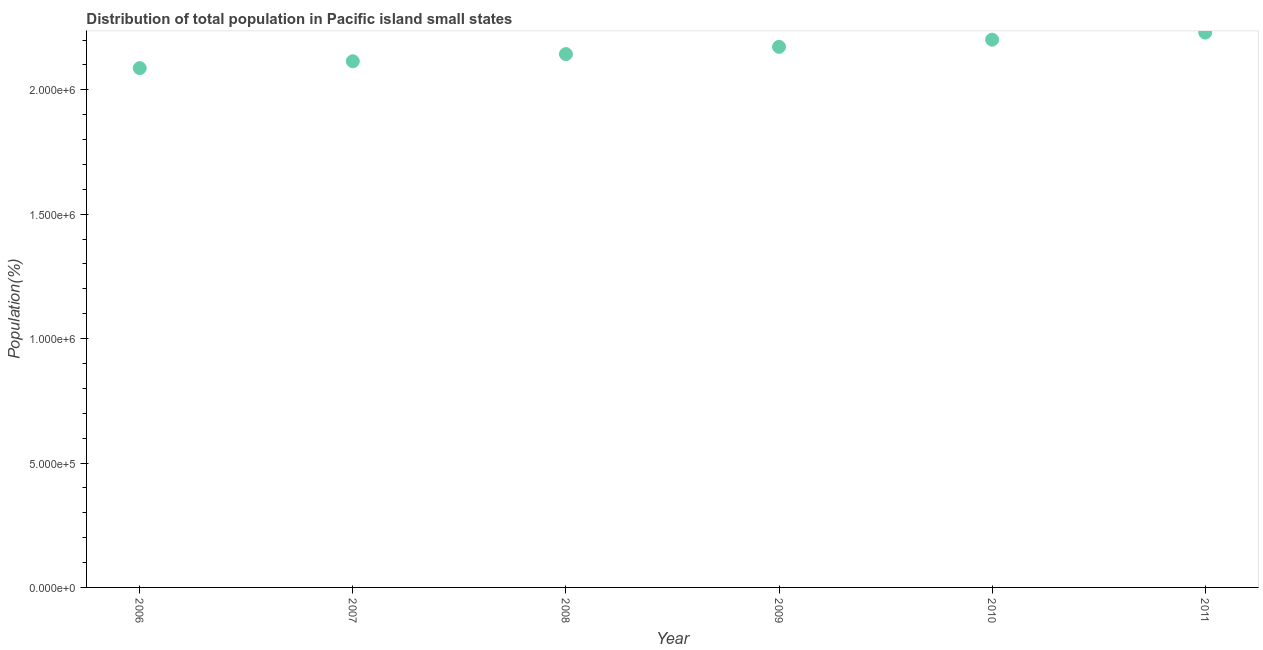What is the population in 2008?
Make the answer very short. 2.14e+06. Across all years, what is the maximum population?
Provide a short and direct response. 2.23e+06. Across all years, what is the minimum population?
Your answer should be compact. 2.09e+06. In which year was the population maximum?
Your answer should be very brief. 2011. What is the sum of the population?
Keep it short and to the point. 1.29e+07. What is the difference between the population in 2007 and 2011?
Offer a very short reply. -1.15e+05. What is the average population per year?
Ensure brevity in your answer.  2.16e+06. What is the median population?
Keep it short and to the point. 2.16e+06. In how many years, is the population greater than 1100000 %?
Ensure brevity in your answer.  6. What is the ratio of the population in 2006 to that in 2009?
Offer a terse response. 0.96. Is the population in 2008 less than that in 2011?
Your answer should be compact. Yes. What is the difference between the highest and the second highest population?
Your answer should be very brief. 2.84e+04. What is the difference between the highest and the lowest population?
Keep it short and to the point. 1.43e+05. In how many years, is the population greater than the average population taken over all years?
Offer a terse response. 3. Does the population monotonically increase over the years?
Offer a very short reply. Yes. How many dotlines are there?
Your answer should be compact. 1. What is the difference between two consecutive major ticks on the Y-axis?
Provide a succinct answer. 5.00e+05. What is the title of the graph?
Make the answer very short. Distribution of total population in Pacific island small states . What is the label or title of the X-axis?
Your response must be concise. Year. What is the label or title of the Y-axis?
Provide a succinct answer. Population(%). What is the Population(%) in 2006?
Provide a short and direct response. 2.09e+06. What is the Population(%) in 2007?
Offer a very short reply. 2.11e+06. What is the Population(%) in 2008?
Make the answer very short. 2.14e+06. What is the Population(%) in 2009?
Ensure brevity in your answer.  2.17e+06. What is the Population(%) in 2010?
Ensure brevity in your answer.  2.20e+06. What is the Population(%) in 2011?
Offer a terse response. 2.23e+06. What is the difference between the Population(%) in 2006 and 2007?
Make the answer very short. -2.75e+04. What is the difference between the Population(%) in 2006 and 2008?
Offer a terse response. -5.63e+04. What is the difference between the Population(%) in 2006 and 2009?
Your response must be concise. -8.54e+04. What is the difference between the Population(%) in 2006 and 2010?
Your answer should be compact. -1.14e+05. What is the difference between the Population(%) in 2006 and 2011?
Make the answer very short. -1.43e+05. What is the difference between the Population(%) in 2007 and 2008?
Offer a very short reply. -2.88e+04. What is the difference between the Population(%) in 2007 and 2009?
Your response must be concise. -5.79e+04. What is the difference between the Population(%) in 2007 and 2010?
Keep it short and to the point. -8.68e+04. What is the difference between the Population(%) in 2007 and 2011?
Keep it short and to the point. -1.15e+05. What is the difference between the Population(%) in 2008 and 2009?
Your response must be concise. -2.92e+04. What is the difference between the Population(%) in 2008 and 2010?
Keep it short and to the point. -5.80e+04. What is the difference between the Population(%) in 2008 and 2011?
Give a very brief answer. -8.65e+04. What is the difference between the Population(%) in 2009 and 2010?
Provide a succinct answer. -2.89e+04. What is the difference between the Population(%) in 2009 and 2011?
Your response must be concise. -5.73e+04. What is the difference between the Population(%) in 2010 and 2011?
Provide a succinct answer. -2.84e+04. What is the ratio of the Population(%) in 2006 to that in 2007?
Your answer should be very brief. 0.99. What is the ratio of the Population(%) in 2006 to that in 2009?
Make the answer very short. 0.96. What is the ratio of the Population(%) in 2006 to that in 2010?
Make the answer very short. 0.95. What is the ratio of the Population(%) in 2006 to that in 2011?
Provide a succinct answer. 0.94. What is the ratio of the Population(%) in 2007 to that in 2009?
Ensure brevity in your answer.  0.97. What is the ratio of the Population(%) in 2007 to that in 2010?
Keep it short and to the point. 0.96. What is the ratio of the Population(%) in 2007 to that in 2011?
Offer a terse response. 0.95. What is the ratio of the Population(%) in 2008 to that in 2009?
Provide a short and direct response. 0.99. What is the ratio of the Population(%) in 2008 to that in 2010?
Provide a succinct answer. 0.97. What is the ratio of the Population(%) in 2008 to that in 2011?
Your answer should be compact. 0.96. What is the ratio of the Population(%) in 2009 to that in 2010?
Offer a very short reply. 0.99. What is the ratio of the Population(%) in 2010 to that in 2011?
Your answer should be very brief. 0.99. 